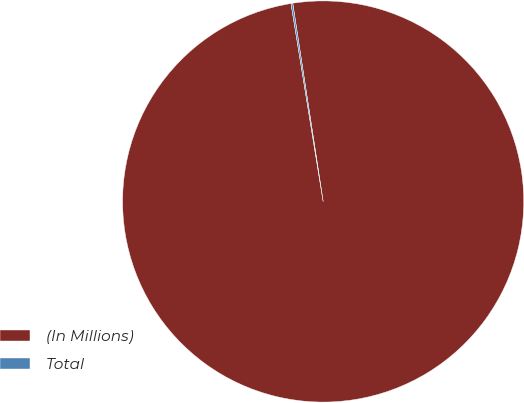Convert chart to OTSL. <chart><loc_0><loc_0><loc_500><loc_500><pie_chart><fcel>(In Millions)<fcel>Total<nl><fcel>99.86%<fcel>0.14%<nl></chart> 